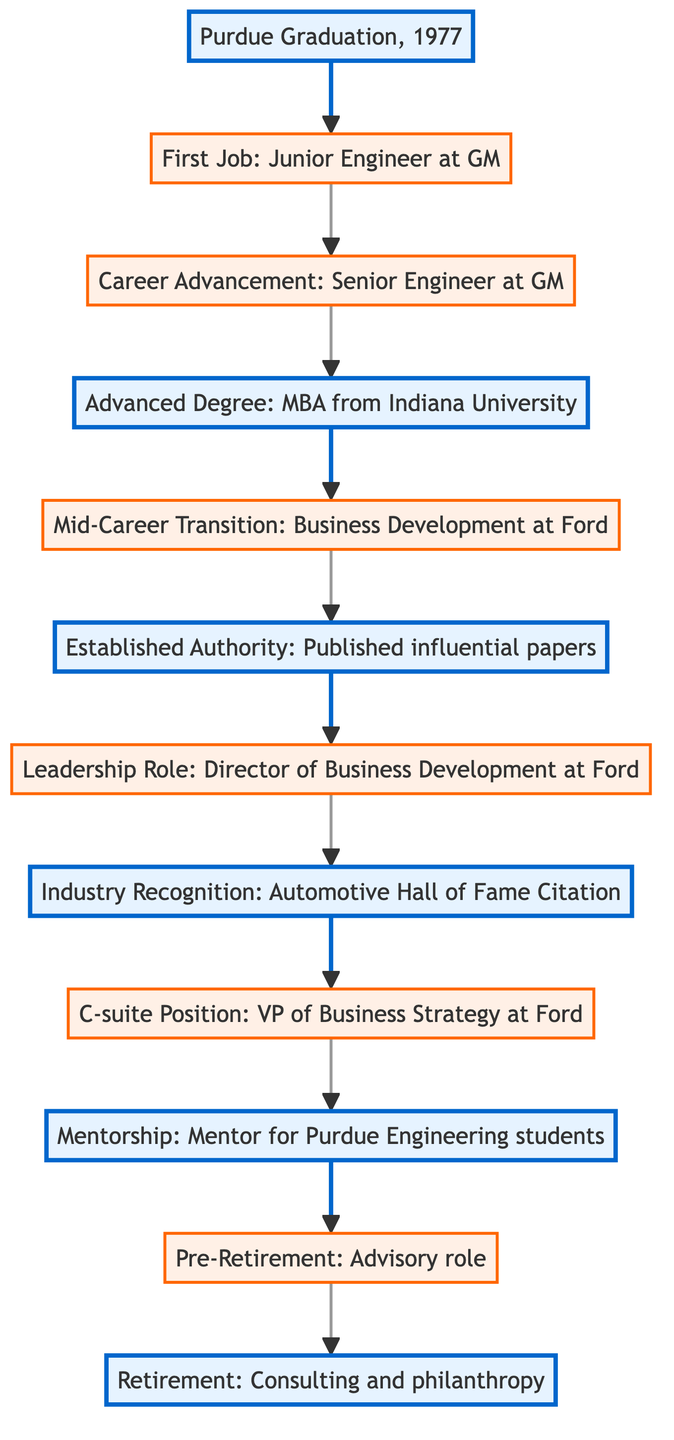What is the starting point of the career path? The starting point is clearly labeled in the diagram as "Purdue Graduation, 1977." This indicates the beginning of the career journey.
Answer: Purdue Graduation, 1977 How many transitions are there in the career path? By reviewing the steps in the diagram, I count a total of 7 transitions that connect various career phases in the pathway.
Answer: 7 What degree was completed in 1985? The step in the diagram for the year 1985 specifically states "Completed MBA at Indiana University," which identifies the degree earned.
Answer: MBA What position was held at Ford in 2010? The diagram clearly labels the position for 2010 as "Vice President of Business Strategy at Ford Motor Company," which answers the question of the title held that year.
Answer: Vice President of Business Strategy at Ford Motor Company What does the mentorship phase signify in the career path? The mentorship phase, noted in 2015 as "Mentor for Purdue Engineering students," indicates a role that involves guiding and supporting students based on past experiences.
Answer: Mentor for Purdue Engineering students Which year marks the transition to retirement? The transition to retirement is outlined in the diagram as occurring in 2021, specifically labeled "Fully retired, focusing on consulting and philanthropy."
Answer: 2021 How many milestones are there in the career path? Examining the diagram, I identify 5 distinct milestones, such as "Purdue Graduation," "Advanced Degree," and others, indicating major achievements throughout the career.
Answer: 5 What role was taken in 1995 at Ford? The diagram marks the 1995 step as "Director of Business Development at Ford Motor Company," making it clear what the role was during that year.
Answer: Director of Business Development at Ford Motor Company What recognition was received in the year 2000? The diagram specifically mentions "Automotive Hall of Fame Distinguished Service Citation," denoting the recognition that was awarded in that year.
Answer: Automotive Hall of Fame Distinguished Service Citation 